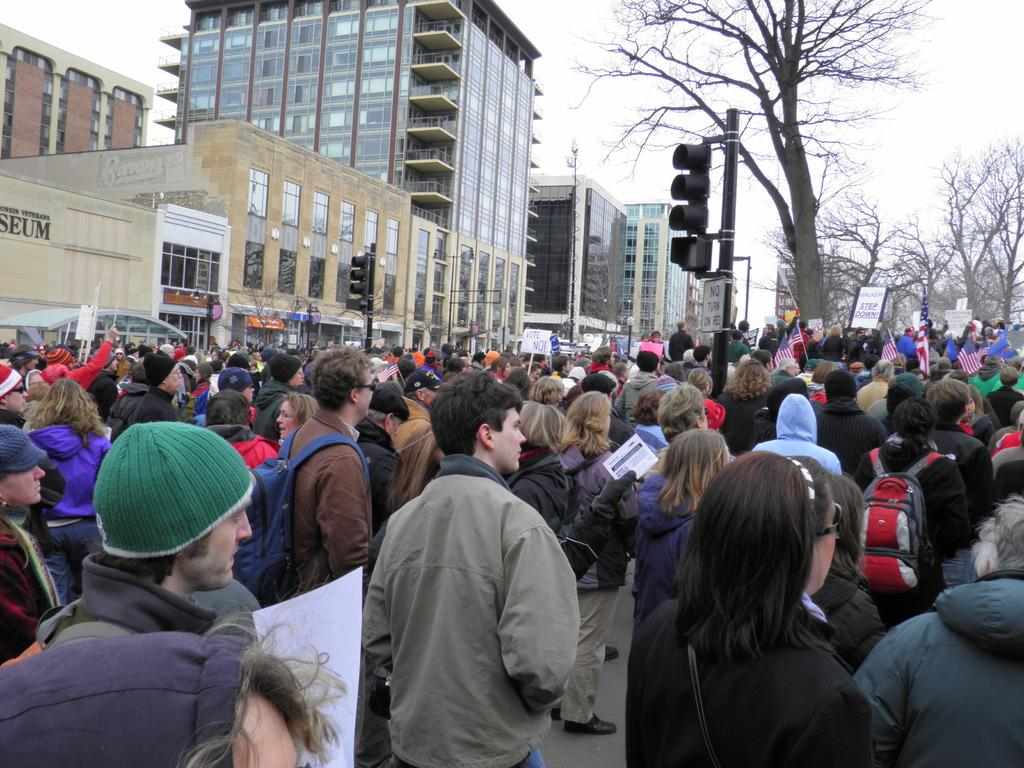How many people are in the image? There is a group of persons standing in the image. What can be seen in the background of the image? There are buildings, trees, and poles in the background of the image. What is the condition of the sky in the image? The sky is cloudy in the image. What is the price of the wheel in the image? There is no wheel present in the image, so it is not possible to determine its price. 